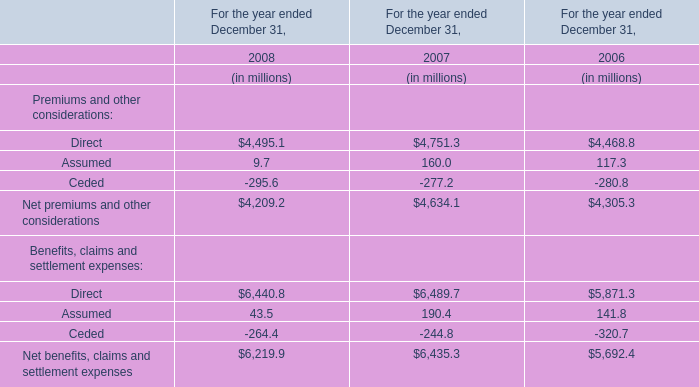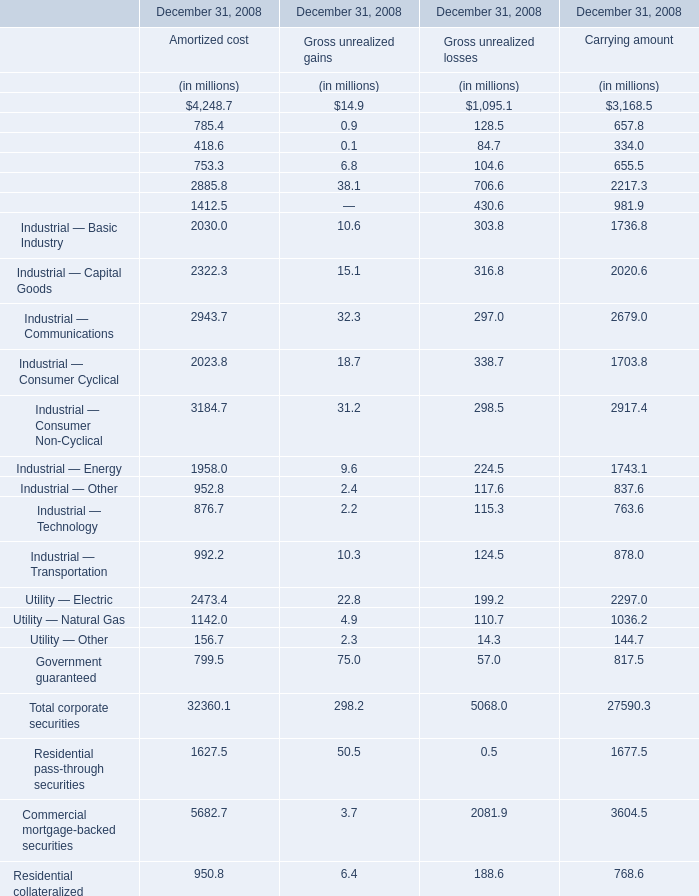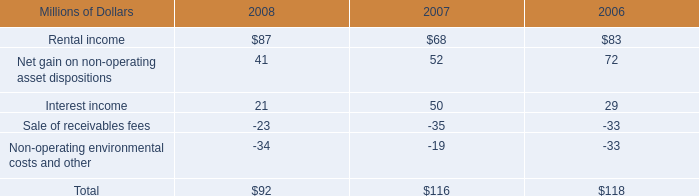What's the 50 % of the value of the Gross unrealized gains for Total corporate securities at December 31, 2008? (in million) 
Computations: (0.5 * 298.2)
Answer: 149.1. 